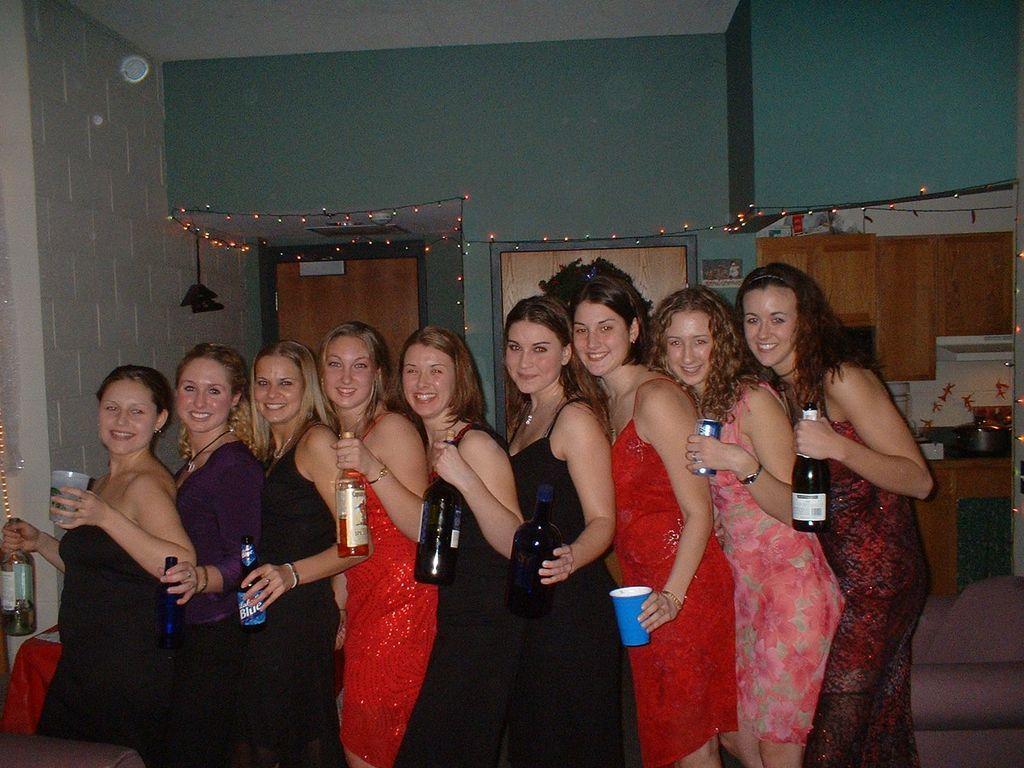Can you describe this image briefly? In this image there are a few women's standing with a smile on their face and they are holding bottles and a few are holding glasses in their hands, behind them there is a wall with some decoration of lights, there is a door and some objects and utensils are arranged on the platform, there are a few stickers attached to the wall, there is an object hanging on the left side of the image. At the top of the image there is a ceiling. 